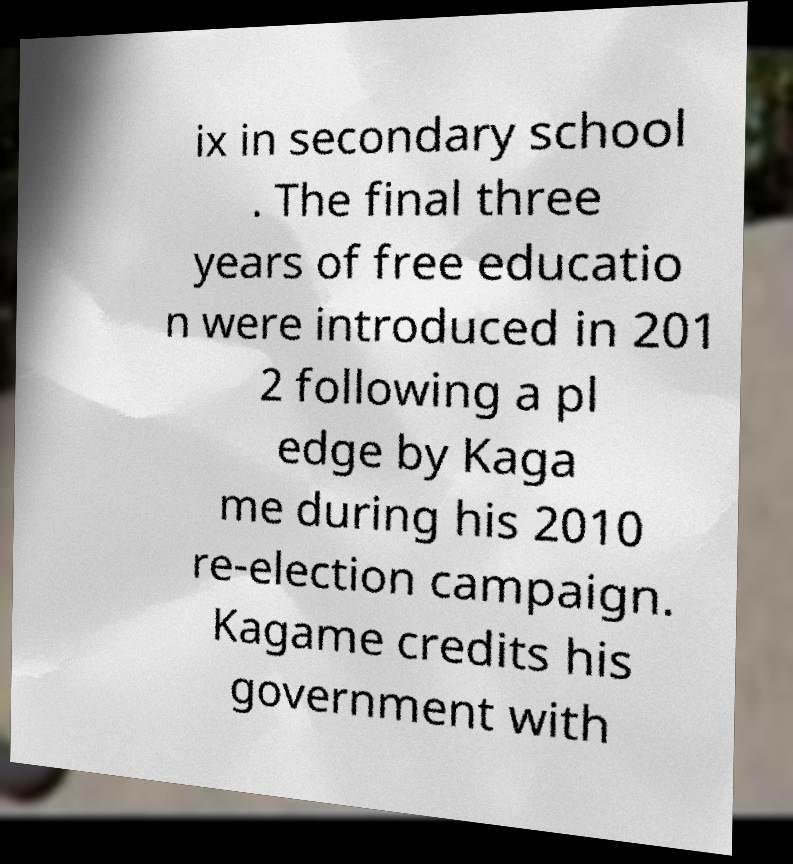Can you read and provide the text displayed in the image?This photo seems to have some interesting text. Can you extract and type it out for me? ix in secondary school . The final three years of free educatio n were introduced in 201 2 following a pl edge by Kaga me during his 2010 re-election campaign. Kagame credits his government with 